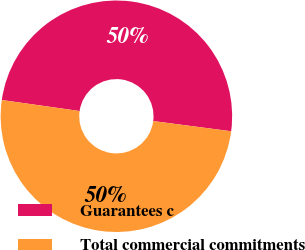Convert chart. <chart><loc_0><loc_0><loc_500><loc_500><pie_chart><fcel>Guarantees c<fcel>Total commercial commitments<nl><fcel>49.83%<fcel>50.17%<nl></chart> 